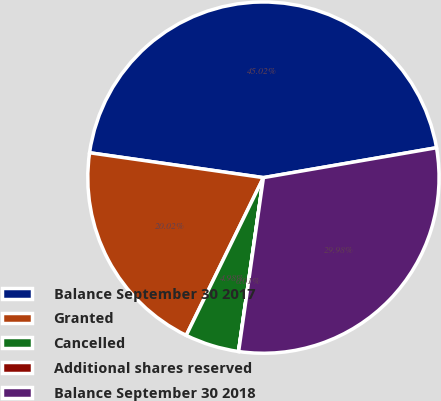Convert chart to OTSL. <chart><loc_0><loc_0><loc_500><loc_500><pie_chart><fcel>Balance September 30 2017<fcel>Granted<fcel>Cancelled<fcel>Additional shares reserved<fcel>Balance September 30 2018<nl><fcel>45.02%<fcel>20.02%<fcel>4.98%<fcel>0.01%<fcel>29.98%<nl></chart> 